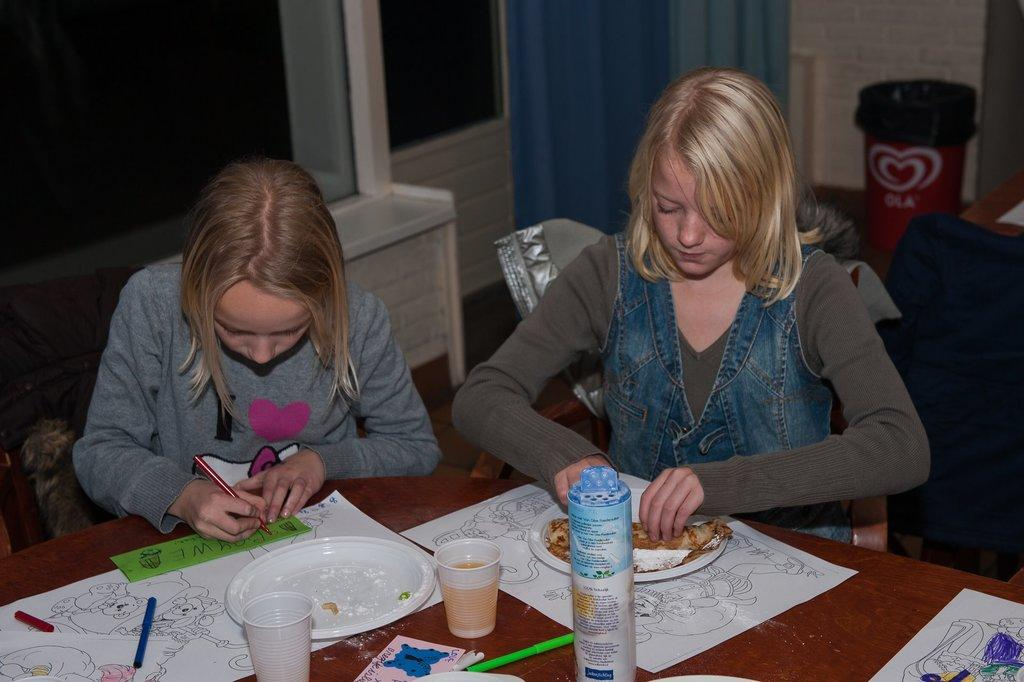How many kids are present in the image? There are two kids in the image. What are the kids doing in the image? One kid is writing, and the other kid is folding something. Where are the kids sitting in the image? The kids are sitting on a table. What is the setting of the image? The setting appears to be in a living room. How many chickens are present in the image? There are no chickens present in the image. What type of seat is the kid using to write in the image? There is no specific mention of a seat in the image. 